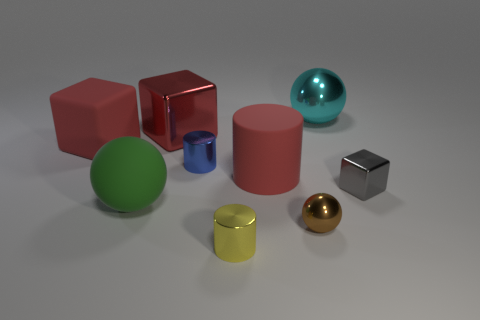Add 1 large red matte cylinders. How many objects exist? 10 Subtract all cubes. How many objects are left? 6 Subtract all tiny gray blocks. Subtract all big things. How many objects are left? 3 Add 3 small cylinders. How many small cylinders are left? 5 Add 5 small brown metal things. How many small brown metal things exist? 6 Subtract 0 purple cylinders. How many objects are left? 9 